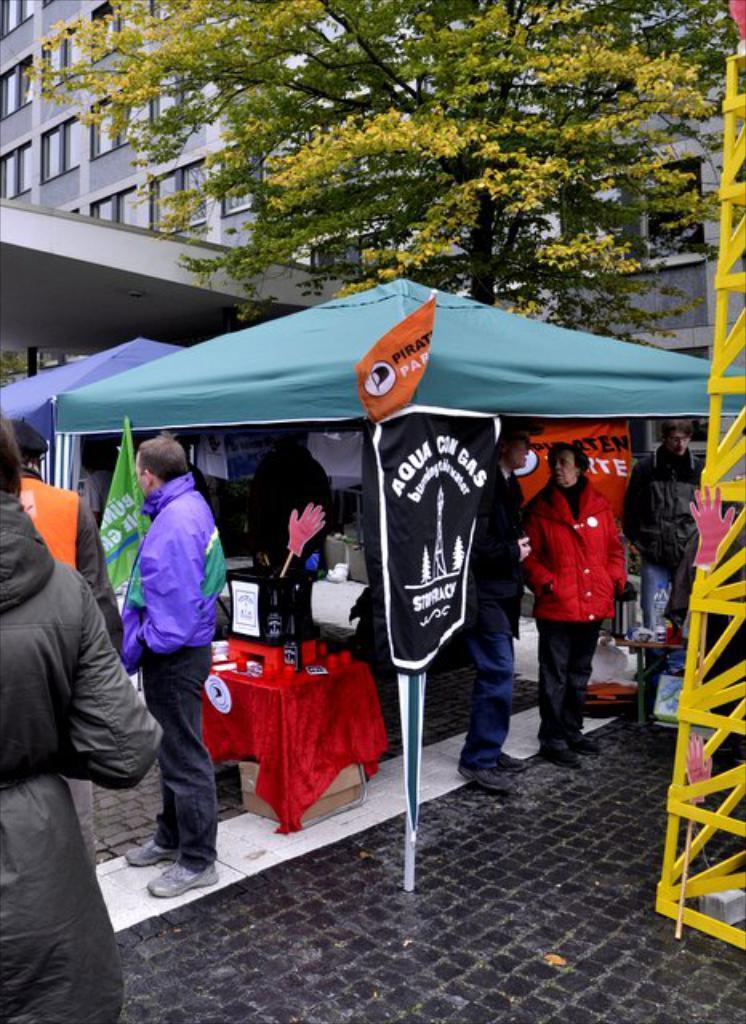Can you describe this image briefly? This image consists of many people standing on the ground. In the front, there are tents. In the background, there is a building along with a tree. To the right, there is a stand. 